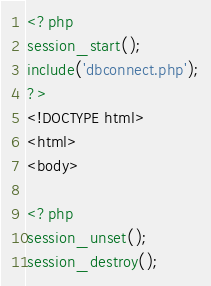Convert code to text. <code><loc_0><loc_0><loc_500><loc_500><_PHP_><?php
session_start();
include('dbconnect.php');
?>
<!DOCTYPE html>
<html>
<body>

<?php
session_unset(); 
session_destroy();</code> 